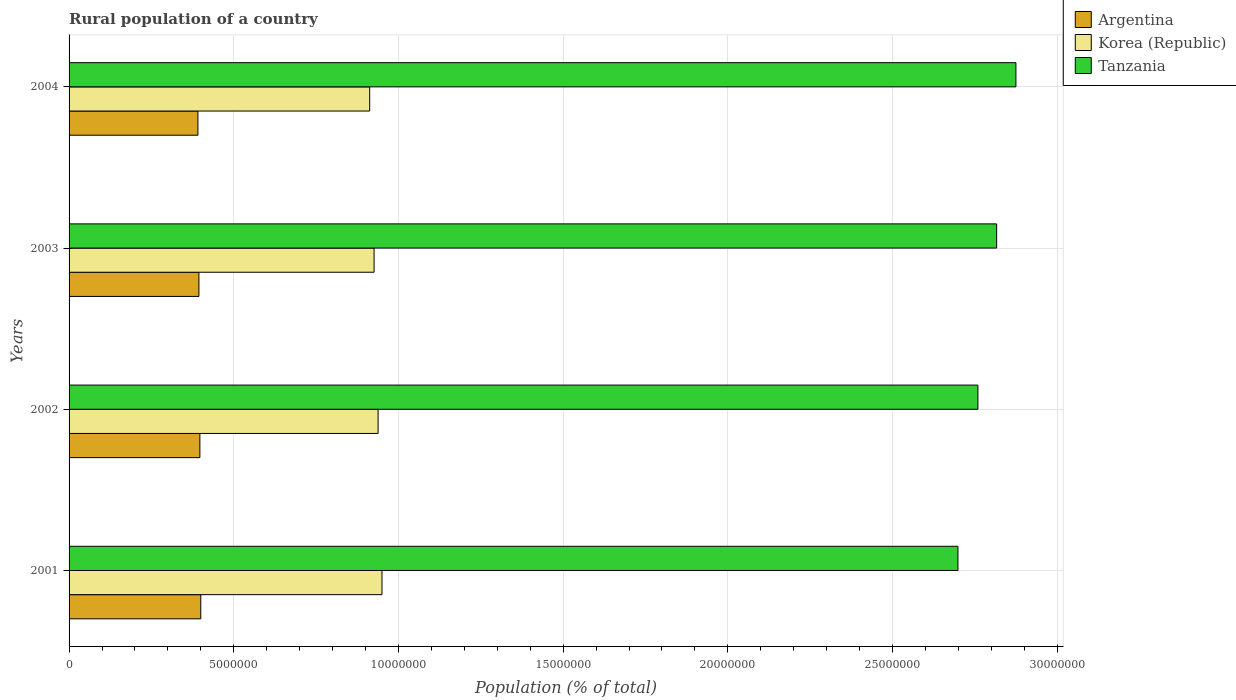How many different coloured bars are there?
Make the answer very short. 3. Are the number of bars on each tick of the Y-axis equal?
Your answer should be compact. Yes. How many bars are there on the 4th tick from the top?
Keep it short and to the point. 3. What is the label of the 2nd group of bars from the top?
Your response must be concise. 2003. In how many cases, is the number of bars for a given year not equal to the number of legend labels?
Give a very brief answer. 0. What is the rural population in Argentina in 2004?
Make the answer very short. 3.91e+06. Across all years, what is the maximum rural population in Korea (Republic)?
Your answer should be compact. 9.50e+06. Across all years, what is the minimum rural population in Tanzania?
Provide a succinct answer. 2.70e+07. In which year was the rural population in Tanzania maximum?
Provide a succinct answer. 2004. In which year was the rural population in Tanzania minimum?
Your answer should be very brief. 2001. What is the total rural population in Korea (Republic) in the graph?
Provide a short and direct response. 3.73e+07. What is the difference between the rural population in Korea (Republic) in 2002 and that in 2003?
Offer a very short reply. 1.22e+05. What is the difference between the rural population in Korea (Republic) in 2004 and the rural population in Argentina in 2003?
Provide a short and direct response. 5.18e+06. What is the average rural population in Korea (Republic) per year?
Provide a short and direct response. 9.32e+06. In the year 2003, what is the difference between the rural population in Argentina and rural population in Korea (Republic)?
Offer a very short reply. -5.32e+06. What is the ratio of the rural population in Korea (Republic) in 2001 to that in 2002?
Your answer should be compact. 1.01. Is the difference between the rural population in Argentina in 2001 and 2004 greater than the difference between the rural population in Korea (Republic) in 2001 and 2004?
Your answer should be compact. No. What is the difference between the highest and the second highest rural population in Korea (Republic)?
Offer a terse response. 1.18e+05. What is the difference between the highest and the lowest rural population in Korea (Republic)?
Your answer should be very brief. 3.73e+05. In how many years, is the rural population in Korea (Republic) greater than the average rural population in Korea (Republic) taken over all years?
Keep it short and to the point. 2. What does the 3rd bar from the top in 2003 represents?
Give a very brief answer. Argentina. What does the 3rd bar from the bottom in 2002 represents?
Offer a very short reply. Tanzania. How many years are there in the graph?
Keep it short and to the point. 4. What is the difference between two consecutive major ticks on the X-axis?
Keep it short and to the point. 5.00e+06. Does the graph contain grids?
Provide a succinct answer. Yes. Where does the legend appear in the graph?
Give a very brief answer. Top right. How many legend labels are there?
Your answer should be very brief. 3. How are the legend labels stacked?
Provide a succinct answer. Vertical. What is the title of the graph?
Give a very brief answer. Rural population of a country. What is the label or title of the X-axis?
Offer a terse response. Population (% of total). What is the label or title of the Y-axis?
Your response must be concise. Years. What is the Population (% of total) in Argentina in 2001?
Your answer should be very brief. 4.00e+06. What is the Population (% of total) in Korea (Republic) in 2001?
Provide a short and direct response. 9.50e+06. What is the Population (% of total) of Tanzania in 2001?
Make the answer very short. 2.70e+07. What is the Population (% of total) in Argentina in 2002?
Offer a terse response. 3.97e+06. What is the Population (% of total) in Korea (Republic) in 2002?
Give a very brief answer. 9.38e+06. What is the Population (% of total) of Tanzania in 2002?
Offer a very short reply. 2.76e+07. What is the Population (% of total) of Argentina in 2003?
Your answer should be very brief. 3.94e+06. What is the Population (% of total) of Korea (Republic) in 2003?
Give a very brief answer. 9.26e+06. What is the Population (% of total) in Tanzania in 2003?
Your answer should be very brief. 2.82e+07. What is the Population (% of total) of Argentina in 2004?
Ensure brevity in your answer.  3.91e+06. What is the Population (% of total) of Korea (Republic) in 2004?
Give a very brief answer. 9.13e+06. What is the Population (% of total) in Tanzania in 2004?
Make the answer very short. 2.87e+07. Across all years, what is the maximum Population (% of total) of Argentina?
Your answer should be compact. 4.00e+06. Across all years, what is the maximum Population (% of total) of Korea (Republic)?
Your answer should be very brief. 9.50e+06. Across all years, what is the maximum Population (% of total) in Tanzania?
Make the answer very short. 2.87e+07. Across all years, what is the minimum Population (% of total) in Argentina?
Your response must be concise. 3.91e+06. Across all years, what is the minimum Population (% of total) of Korea (Republic)?
Your response must be concise. 9.13e+06. Across all years, what is the minimum Population (% of total) in Tanzania?
Make the answer very short. 2.70e+07. What is the total Population (% of total) in Argentina in the graph?
Your answer should be very brief. 1.58e+07. What is the total Population (% of total) of Korea (Republic) in the graph?
Ensure brevity in your answer.  3.73e+07. What is the total Population (% of total) of Tanzania in the graph?
Ensure brevity in your answer.  1.11e+08. What is the difference between the Population (% of total) in Argentina in 2001 and that in 2002?
Offer a very short reply. 2.74e+04. What is the difference between the Population (% of total) in Korea (Republic) in 2001 and that in 2002?
Make the answer very short. 1.18e+05. What is the difference between the Population (% of total) of Tanzania in 2001 and that in 2002?
Offer a terse response. -6.07e+05. What is the difference between the Population (% of total) in Argentina in 2001 and that in 2003?
Your response must be concise. 5.65e+04. What is the difference between the Population (% of total) in Korea (Republic) in 2001 and that in 2003?
Give a very brief answer. 2.40e+05. What is the difference between the Population (% of total) in Tanzania in 2001 and that in 2003?
Provide a short and direct response. -1.18e+06. What is the difference between the Population (% of total) of Argentina in 2001 and that in 2004?
Keep it short and to the point. 8.66e+04. What is the difference between the Population (% of total) of Korea (Republic) in 2001 and that in 2004?
Provide a succinct answer. 3.73e+05. What is the difference between the Population (% of total) of Tanzania in 2001 and that in 2004?
Keep it short and to the point. -1.76e+06. What is the difference between the Population (% of total) of Argentina in 2002 and that in 2003?
Your response must be concise. 2.91e+04. What is the difference between the Population (% of total) in Korea (Republic) in 2002 and that in 2003?
Ensure brevity in your answer.  1.22e+05. What is the difference between the Population (% of total) in Tanzania in 2002 and that in 2003?
Provide a succinct answer. -5.69e+05. What is the difference between the Population (% of total) of Argentina in 2002 and that in 2004?
Your answer should be very brief. 5.92e+04. What is the difference between the Population (% of total) in Korea (Republic) in 2002 and that in 2004?
Your answer should be compact. 2.56e+05. What is the difference between the Population (% of total) in Tanzania in 2002 and that in 2004?
Your answer should be compact. -1.15e+06. What is the difference between the Population (% of total) in Argentina in 2003 and that in 2004?
Ensure brevity in your answer.  3.01e+04. What is the difference between the Population (% of total) of Korea (Republic) in 2003 and that in 2004?
Ensure brevity in your answer.  1.33e+05. What is the difference between the Population (% of total) in Tanzania in 2003 and that in 2004?
Provide a short and direct response. -5.85e+05. What is the difference between the Population (% of total) in Argentina in 2001 and the Population (% of total) in Korea (Republic) in 2002?
Your answer should be compact. -5.38e+06. What is the difference between the Population (% of total) in Argentina in 2001 and the Population (% of total) in Tanzania in 2002?
Your answer should be compact. -2.36e+07. What is the difference between the Population (% of total) in Korea (Republic) in 2001 and the Population (% of total) in Tanzania in 2002?
Ensure brevity in your answer.  -1.81e+07. What is the difference between the Population (% of total) of Argentina in 2001 and the Population (% of total) of Korea (Republic) in 2003?
Your answer should be very brief. -5.26e+06. What is the difference between the Population (% of total) of Argentina in 2001 and the Population (% of total) of Tanzania in 2003?
Your answer should be compact. -2.42e+07. What is the difference between the Population (% of total) of Korea (Republic) in 2001 and the Population (% of total) of Tanzania in 2003?
Make the answer very short. -1.87e+07. What is the difference between the Population (% of total) of Argentina in 2001 and the Population (% of total) of Korea (Republic) in 2004?
Give a very brief answer. -5.13e+06. What is the difference between the Population (% of total) in Argentina in 2001 and the Population (% of total) in Tanzania in 2004?
Your answer should be very brief. -2.47e+07. What is the difference between the Population (% of total) of Korea (Republic) in 2001 and the Population (% of total) of Tanzania in 2004?
Make the answer very short. -1.92e+07. What is the difference between the Population (% of total) in Argentina in 2002 and the Population (% of total) in Korea (Republic) in 2003?
Your answer should be compact. -5.29e+06. What is the difference between the Population (% of total) in Argentina in 2002 and the Population (% of total) in Tanzania in 2003?
Offer a very short reply. -2.42e+07. What is the difference between the Population (% of total) in Korea (Republic) in 2002 and the Population (% of total) in Tanzania in 2003?
Offer a terse response. -1.88e+07. What is the difference between the Population (% of total) of Argentina in 2002 and the Population (% of total) of Korea (Republic) in 2004?
Your response must be concise. -5.16e+06. What is the difference between the Population (% of total) in Argentina in 2002 and the Population (% of total) in Tanzania in 2004?
Make the answer very short. -2.48e+07. What is the difference between the Population (% of total) of Korea (Republic) in 2002 and the Population (% of total) of Tanzania in 2004?
Offer a very short reply. -1.94e+07. What is the difference between the Population (% of total) of Argentina in 2003 and the Population (% of total) of Korea (Republic) in 2004?
Your answer should be very brief. -5.18e+06. What is the difference between the Population (% of total) of Argentina in 2003 and the Population (% of total) of Tanzania in 2004?
Ensure brevity in your answer.  -2.48e+07. What is the difference between the Population (% of total) of Korea (Republic) in 2003 and the Population (% of total) of Tanzania in 2004?
Provide a short and direct response. -1.95e+07. What is the average Population (% of total) in Argentina per year?
Provide a succinct answer. 3.96e+06. What is the average Population (% of total) of Korea (Republic) per year?
Your answer should be compact. 9.32e+06. What is the average Population (% of total) in Tanzania per year?
Keep it short and to the point. 2.79e+07. In the year 2001, what is the difference between the Population (% of total) in Argentina and Population (% of total) in Korea (Republic)?
Ensure brevity in your answer.  -5.50e+06. In the year 2001, what is the difference between the Population (% of total) in Argentina and Population (% of total) in Tanzania?
Provide a succinct answer. -2.30e+07. In the year 2001, what is the difference between the Population (% of total) of Korea (Republic) and Population (% of total) of Tanzania?
Offer a terse response. -1.75e+07. In the year 2002, what is the difference between the Population (% of total) in Argentina and Population (% of total) in Korea (Republic)?
Offer a very short reply. -5.41e+06. In the year 2002, what is the difference between the Population (% of total) of Argentina and Population (% of total) of Tanzania?
Your response must be concise. -2.36e+07. In the year 2002, what is the difference between the Population (% of total) of Korea (Republic) and Population (% of total) of Tanzania?
Provide a short and direct response. -1.82e+07. In the year 2003, what is the difference between the Population (% of total) of Argentina and Population (% of total) of Korea (Republic)?
Your answer should be very brief. -5.32e+06. In the year 2003, what is the difference between the Population (% of total) in Argentina and Population (% of total) in Tanzania?
Your answer should be very brief. -2.42e+07. In the year 2003, what is the difference between the Population (% of total) of Korea (Republic) and Population (% of total) of Tanzania?
Your response must be concise. -1.89e+07. In the year 2004, what is the difference between the Population (% of total) in Argentina and Population (% of total) in Korea (Republic)?
Your answer should be compact. -5.21e+06. In the year 2004, what is the difference between the Population (% of total) of Argentina and Population (% of total) of Tanzania?
Offer a very short reply. -2.48e+07. In the year 2004, what is the difference between the Population (% of total) of Korea (Republic) and Population (% of total) of Tanzania?
Provide a succinct answer. -1.96e+07. What is the ratio of the Population (% of total) of Korea (Republic) in 2001 to that in 2002?
Your answer should be very brief. 1.01. What is the ratio of the Population (% of total) in Tanzania in 2001 to that in 2002?
Give a very brief answer. 0.98. What is the ratio of the Population (% of total) of Argentina in 2001 to that in 2003?
Your response must be concise. 1.01. What is the ratio of the Population (% of total) of Korea (Republic) in 2001 to that in 2003?
Ensure brevity in your answer.  1.03. What is the ratio of the Population (% of total) of Tanzania in 2001 to that in 2003?
Offer a very short reply. 0.96. What is the ratio of the Population (% of total) in Argentina in 2001 to that in 2004?
Offer a terse response. 1.02. What is the ratio of the Population (% of total) of Korea (Republic) in 2001 to that in 2004?
Offer a terse response. 1.04. What is the ratio of the Population (% of total) of Tanzania in 2001 to that in 2004?
Keep it short and to the point. 0.94. What is the ratio of the Population (% of total) in Argentina in 2002 to that in 2003?
Provide a short and direct response. 1.01. What is the ratio of the Population (% of total) of Korea (Republic) in 2002 to that in 2003?
Offer a terse response. 1.01. What is the ratio of the Population (% of total) in Tanzania in 2002 to that in 2003?
Provide a short and direct response. 0.98. What is the ratio of the Population (% of total) of Argentina in 2002 to that in 2004?
Offer a very short reply. 1.02. What is the ratio of the Population (% of total) of Korea (Republic) in 2002 to that in 2004?
Offer a terse response. 1.03. What is the ratio of the Population (% of total) of Tanzania in 2002 to that in 2004?
Make the answer very short. 0.96. What is the ratio of the Population (% of total) of Argentina in 2003 to that in 2004?
Keep it short and to the point. 1.01. What is the ratio of the Population (% of total) of Korea (Republic) in 2003 to that in 2004?
Make the answer very short. 1.01. What is the ratio of the Population (% of total) of Tanzania in 2003 to that in 2004?
Offer a terse response. 0.98. What is the difference between the highest and the second highest Population (% of total) in Argentina?
Provide a short and direct response. 2.74e+04. What is the difference between the highest and the second highest Population (% of total) of Korea (Republic)?
Your answer should be compact. 1.18e+05. What is the difference between the highest and the second highest Population (% of total) of Tanzania?
Ensure brevity in your answer.  5.85e+05. What is the difference between the highest and the lowest Population (% of total) in Argentina?
Give a very brief answer. 8.66e+04. What is the difference between the highest and the lowest Population (% of total) in Korea (Republic)?
Keep it short and to the point. 3.73e+05. What is the difference between the highest and the lowest Population (% of total) of Tanzania?
Your answer should be compact. 1.76e+06. 